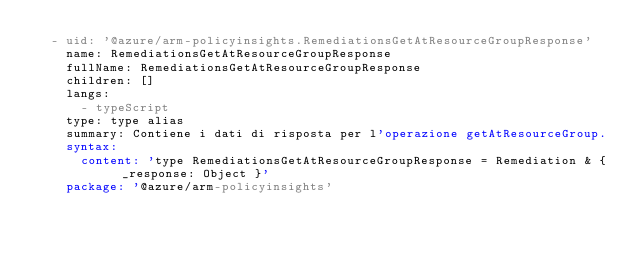<code> <loc_0><loc_0><loc_500><loc_500><_YAML_>  - uid: '@azure/arm-policyinsights.RemediationsGetAtResourceGroupResponse'
    name: RemediationsGetAtResourceGroupResponse
    fullName: RemediationsGetAtResourceGroupResponse
    children: []
    langs:
      - typeScript
    type: type alias
    summary: Contiene i dati di risposta per l'operazione getAtResourceGroup.
    syntax:
      content: 'type RemediationsGetAtResourceGroupResponse = Remediation & { _response: Object }'
    package: '@azure/arm-policyinsights'</code> 